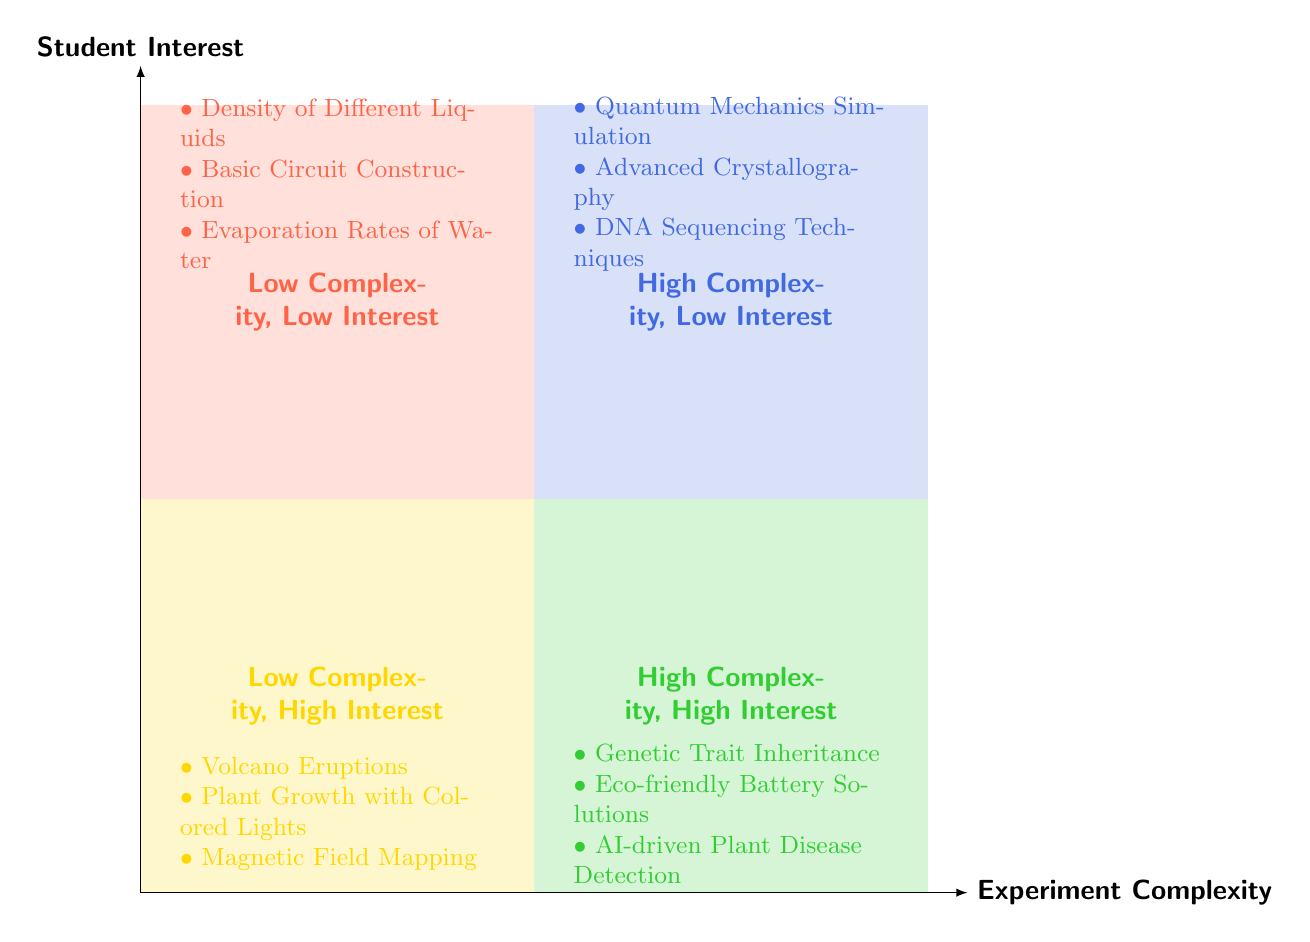What are the examples listed in the Low Complexity, High Interest quadrant? The diagram shows the examples for the quadrants, specifically for Low Complexity, High Interest. It lists Volcano Eruptions, Plant Growth with Colored Lights, and Magnetic Field Mapping.
Answer: Volcano Eruptions, Plant Growth with Colored Lights, Magnetic Field Mapping Which quadrant contains Genetic Trait Inheritance? By examining where Genetic Trait Inheritance is presented in the diagram, it is placed in the High Complexity, High Interest quadrant.
Answer: High Complexity, High Interest How many examples are provided in the Low Complexity, Low Interest quadrant? In the Low Complexity, Low Interest quadrant, there are three examples listed: Density of Different Liquids, Basic Circuit Construction, and Evaporation Rates of Water. This counts as three examples.
Answer: 3 What is the main characteristic of the High Complexity, Low Interest quadrant? The High Complexity, Low Interest quadrant contains projects that are intricate but do not engage students' interest effectively. The examples like Quantum Mechanics Simulation reflect this trait.
Answer: Intricate but unengaging Which quadrant has the highest interest level? The highest interest level can be determined by looking at the Y-axis where both quadrants situated above the midpoint represent high interest. They are Low Complexity, High Interest and High Complexity, High Interest quadrants.
Answer: Low Complexity, High Interest; High Complexity, High Interest How many quadrants indicate low interest? A quick inspection of the quadrants reveals that there are two quadrants that indicate low interest: Low Complexity, Low Interest and High Complexity, Low Interest.
Answer: 2 Which quadrant represents experiments that are both low complexity and high interest? The quadrant positioned in the bottom left section of the diagram represents low complexity and high interest, specifically Low Complexity, High Interest.
Answer: Low Complexity, High Interest What is an example of a project in the High Complexity, Low Interest quadrant? Reviewing the High Complexity, Low Interest quadrant in the diagram, an example listed is Quantum Mechanics Simulation.
Answer: Quantum Mechanics Simulation 